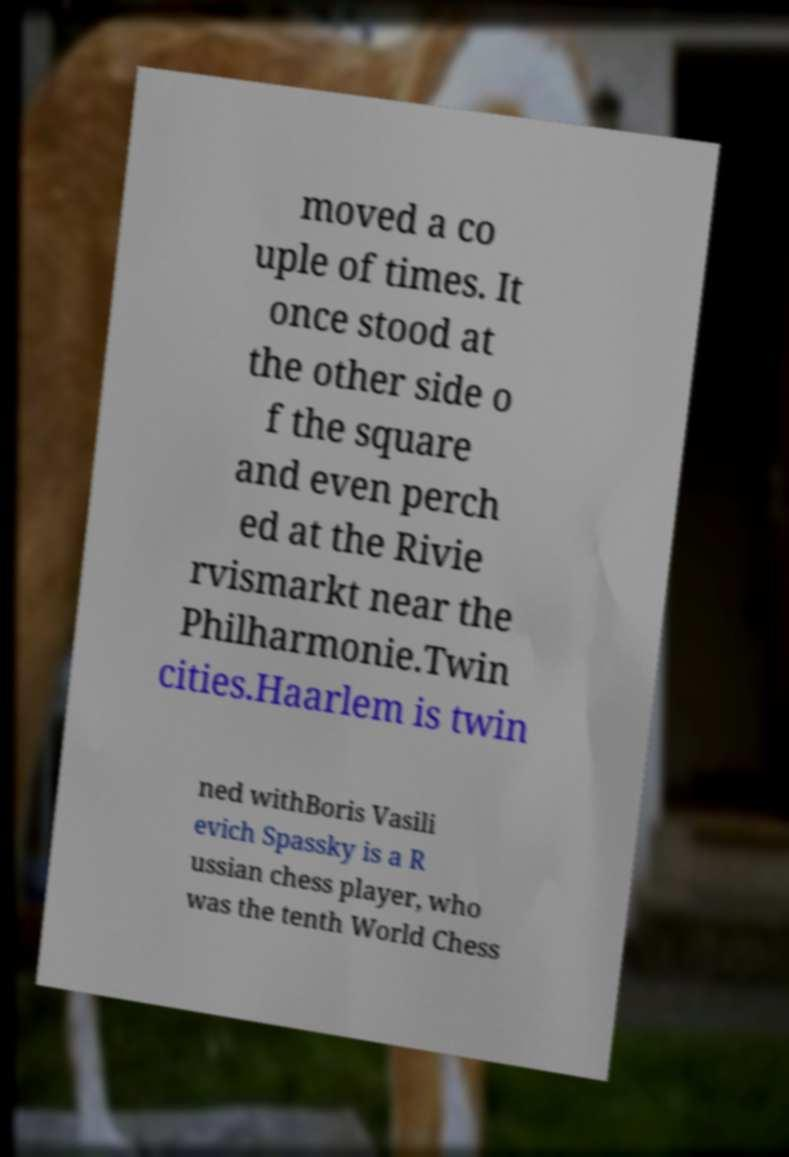There's text embedded in this image that I need extracted. Can you transcribe it verbatim? moved a co uple of times. It once stood at the other side o f the square and even perch ed at the Rivie rvismarkt near the Philharmonie.Twin cities.Haarlem is twin ned withBoris Vasili evich Spassky is a R ussian chess player, who was the tenth World Chess 